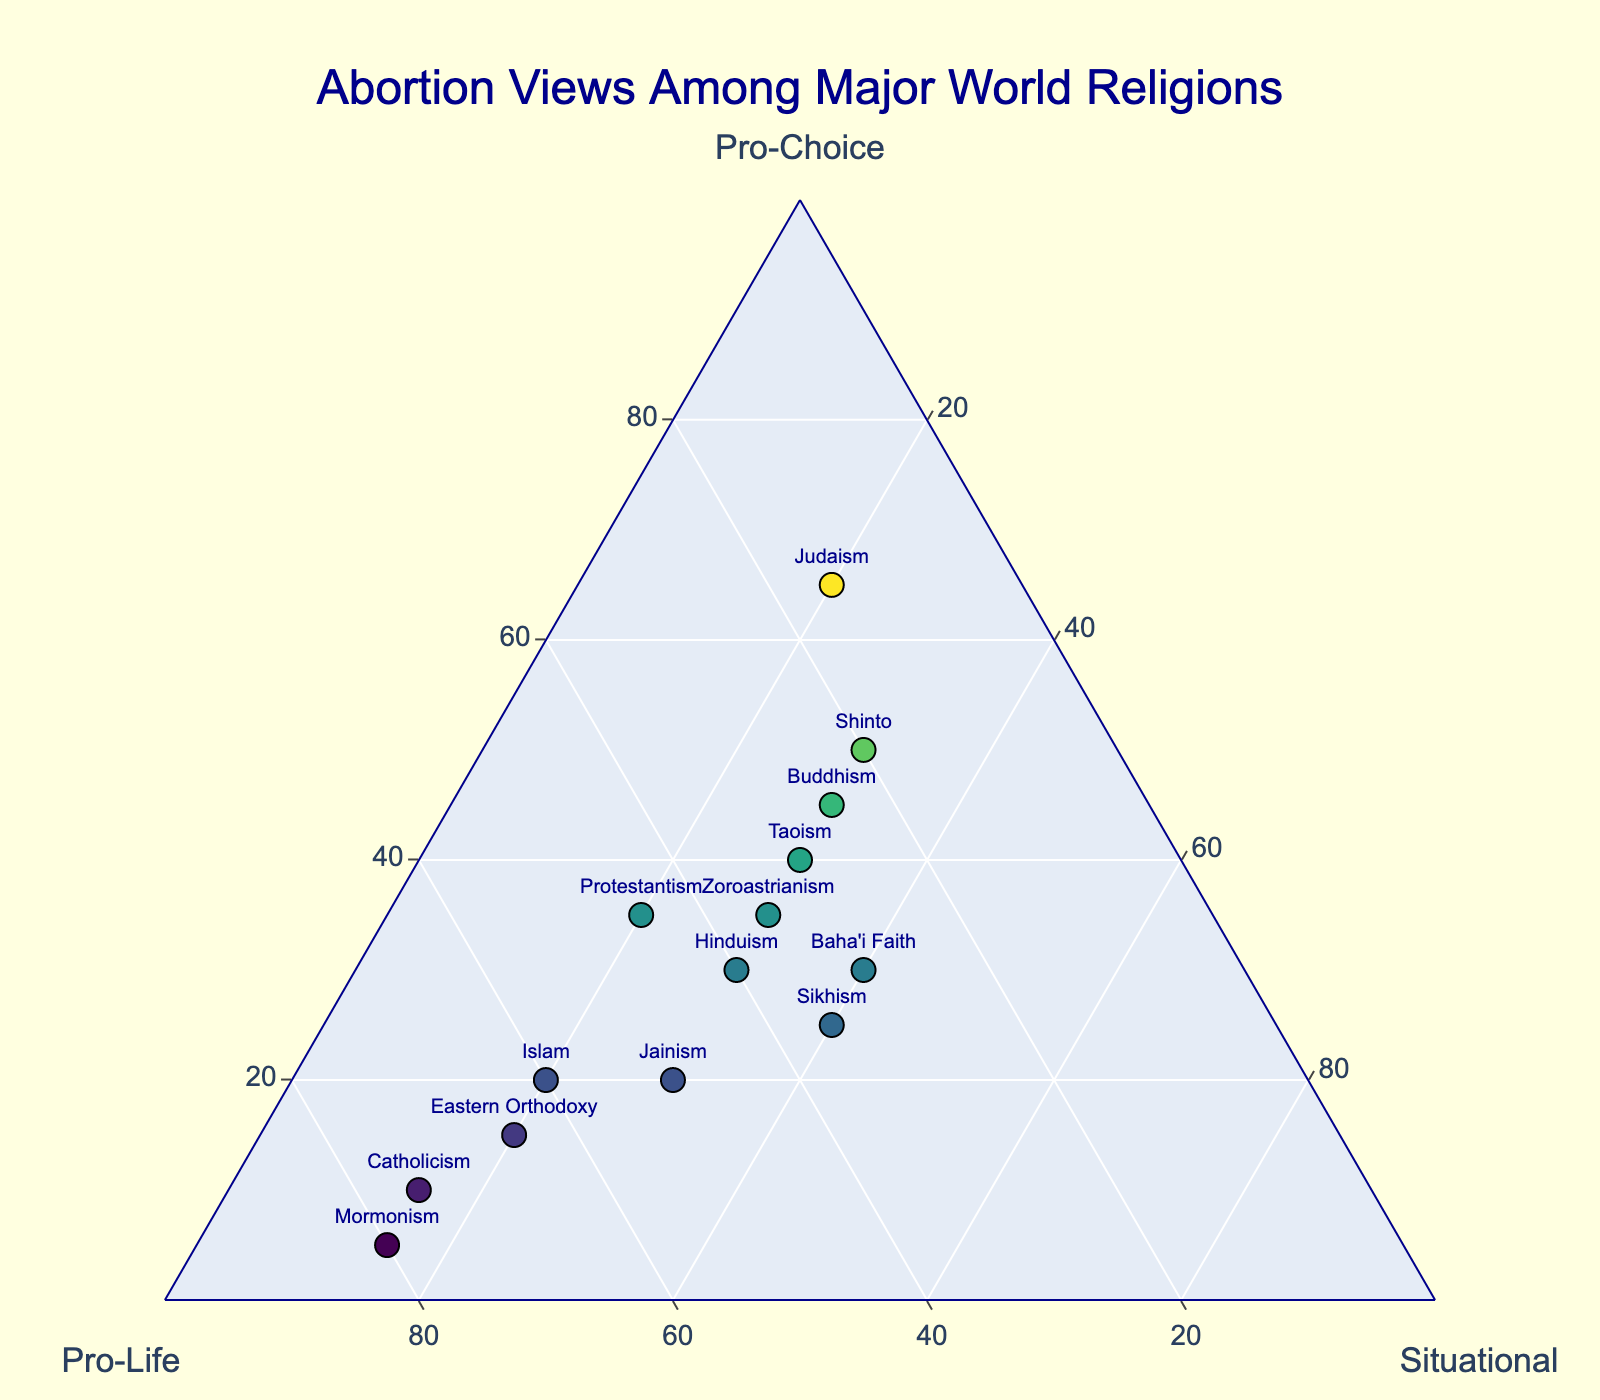What does the title of the plot indicate? The title "Abortion Views Among Major World Religions" indicates that the plot compares the views on abortion (pro-choice, pro-life, and situational) among different world religions.
Answer: It compares abortion views among major world religions What are the axis labels in the ternary plot? The axes are labeled as "Pro-Choice", "Pro-Life", and "Situational", representing the percentages of each viewpoint among the religions.
Answer: Pro-Choice, Pro-Life, Situational Which religion has the highest pro-life percentage? Mormonism has the highest pro-life percentage, which is shown by its position farthest towards the pro-life axis.
Answer: Mormonism Which religion has the highest pro-choice percentage? Judaism has the highest pro-choice percentage as it is closest to the pro-choice axis.
Answer: Judaism How many religions are represented in the plot? The plot represents 14 religions, each indicated by a data point with its respective name.
Answer: 14 What is the common situational perspective percentage for Baha'i Faith and Sikhism? Both the Baha'i Faith and Sikhism have a situational perspective percentage of 40%.
Answer: 40% Which religion has a similar balance between pro-choice and pro-life views? Zoroastrianism has an equal balance between pro-choice and pro-life views, both being at 35%.
Answer: Zoroastrianism Which religions have exactly 25% pro-life views? Buddhism and Shinto both have exactly 25% pro-life views.
Answer: Buddhism, Shinto What is the difference in situational perspective between Hinduism and Protestantism? Hinduism has a situational perspective of 30%, and Protestantism has 20%. The difference is 30% - 20% = 10%.
Answer: 10% Which religion is closest to having equal percentages in all three perspectives? Baha'i Faith is closest with 30% pro-choice, 30% pro-life, and 40% situational, having the least disparity among the three perspectives.
Answer: Baha'i Faith 